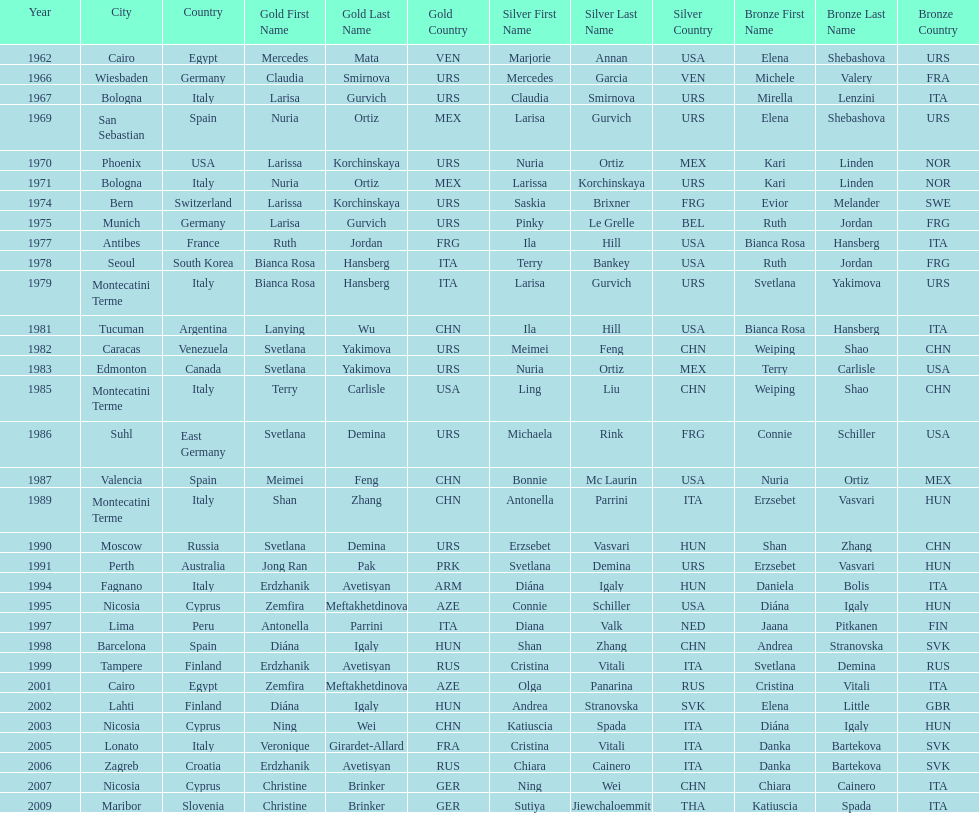How many gold did u.s.a win 1. 